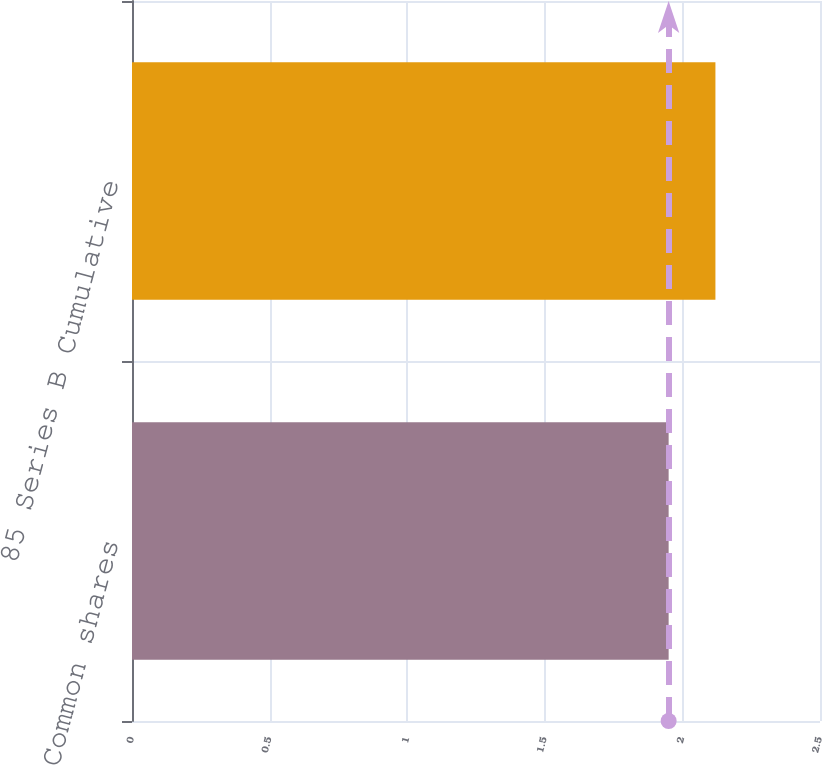Convert chart. <chart><loc_0><loc_0><loc_500><loc_500><bar_chart><fcel>Common shares<fcel>85 Series B Cumulative<nl><fcel>1.95<fcel>2.12<nl></chart> 